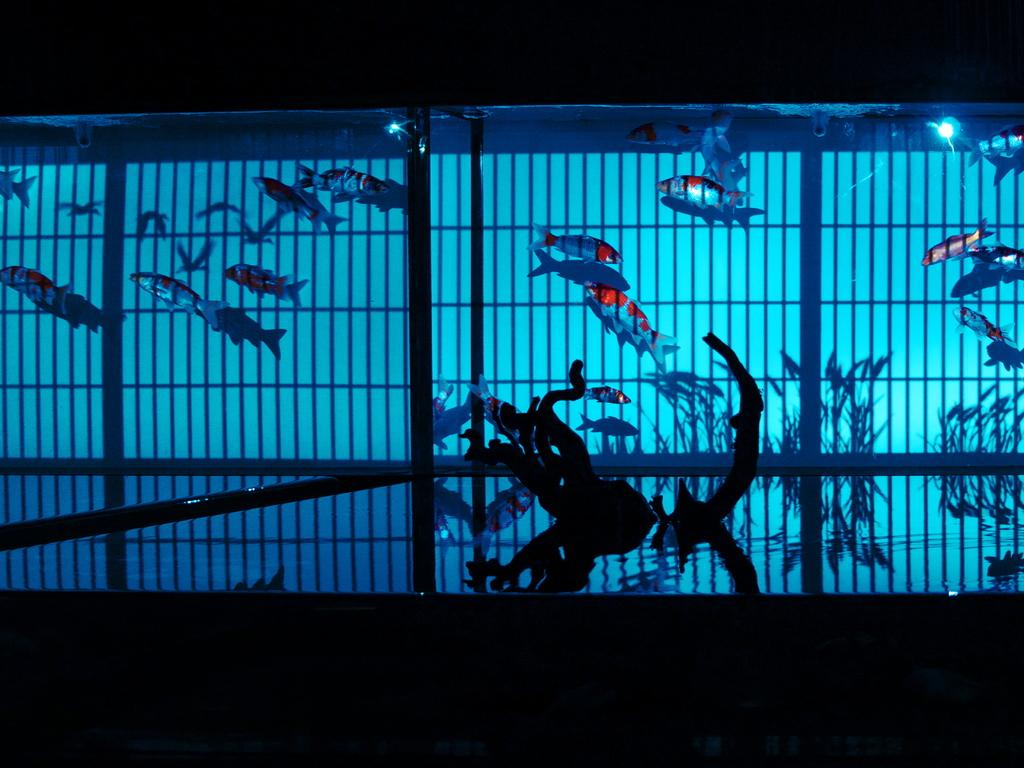What type of animals can be seen in the image? There are fishes in the image. What objects are used in the image? There are rods in the image. What other elements are present in the image? There are plants in the image. Can you describe the unspecified objects in the image? Unfortunately, the facts provided do not specify the nature of these objects. What is the color of the background in the image? The background of the image is dark. How many fingers can be seen on the boy's hand in the image? There is no boy present in the image, so it is not possible to determine the number of fingers on his hand. 